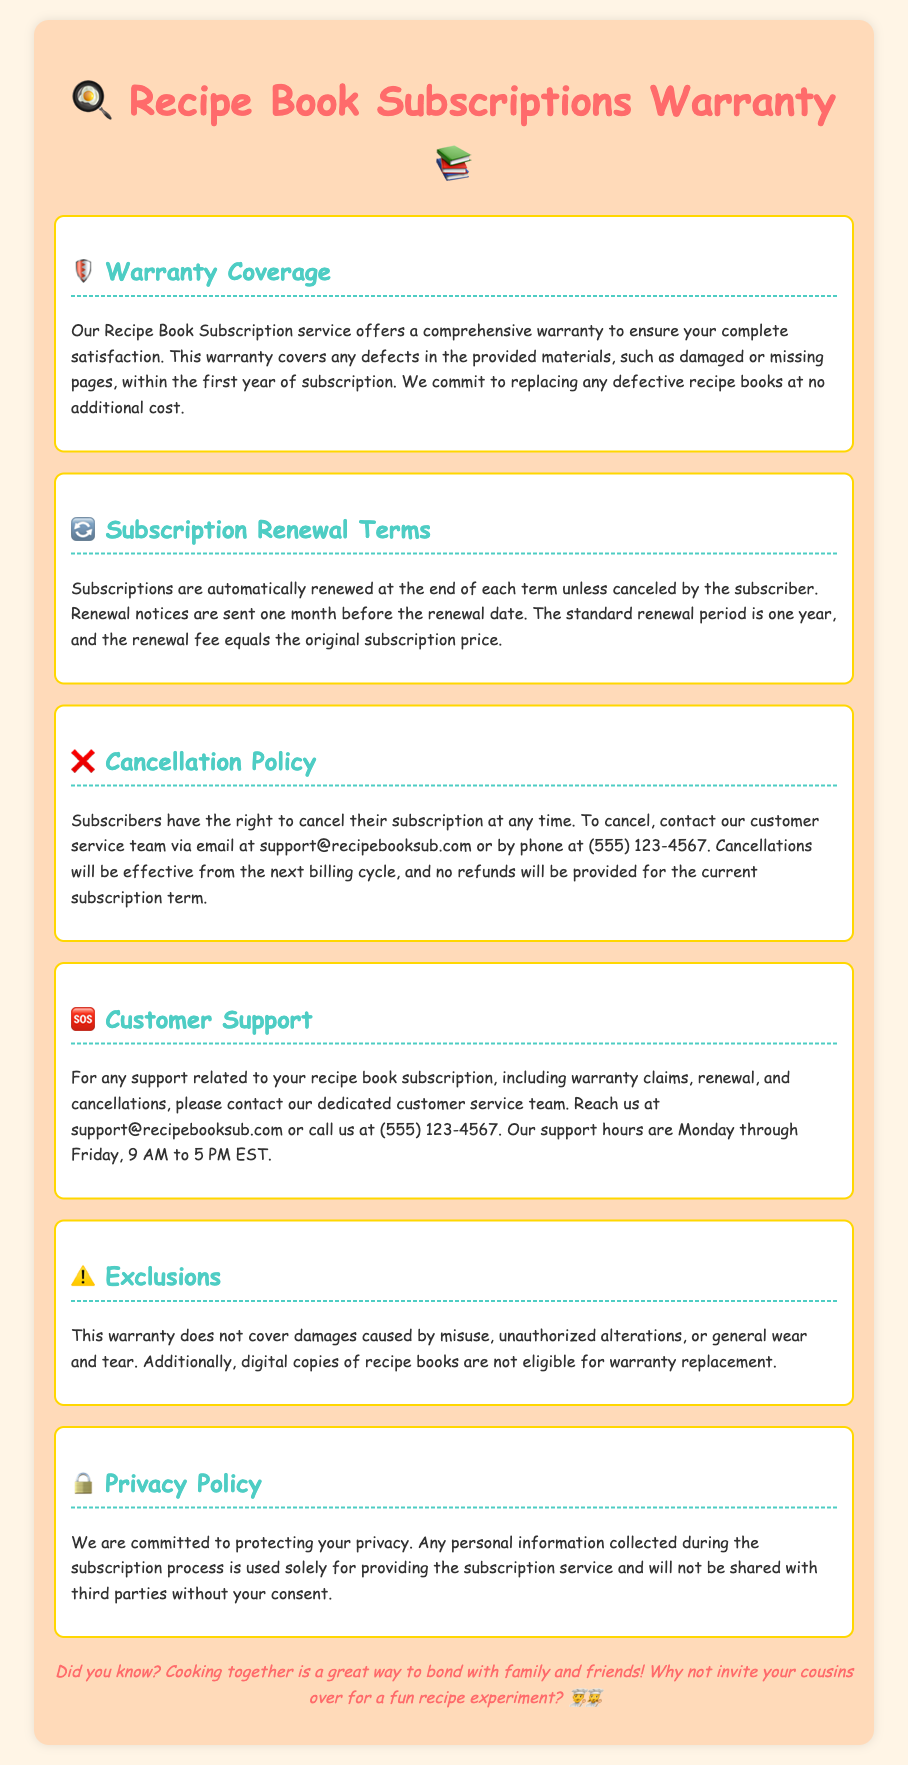What is covered by the warranty? The warranty covers any defects in the provided materials, such as damaged or missing pages, within the first year of subscription.
Answer: defects in the provided materials How long is the standard renewal period? The standard renewal period is stated in the renewal terms section of the document.
Answer: one year What should subscribers do to cancel their subscription? The cancellation policy outlines the steps subscribers need to take.
Answer: contact customer service What is the customer support email? The document provides the contact information for customer support, including the email address.
Answer: support@recipebooksub.com Are digital copies eligible for warranty replacement? The exclusions section specifically mentions certain conditions not covered under the warranty.
Answer: no What is the renewal fee equal to? The renewal terms section describes the renewal fee's relationship to the original subscription price.
Answer: original subscription price When will renewal notices be sent? The renewal terms state when subscribers can expect to receive notifications regarding renewals.
Answer: one month before the renewal date During what hours is customer support available? The customer support section lists the hours when the support team can be contacted.
Answer: Monday through Friday, 9 AM to 5 PM EST 